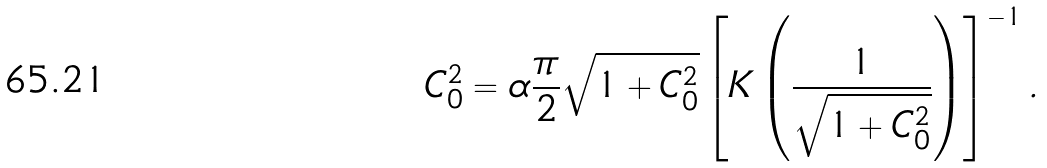<formula> <loc_0><loc_0><loc_500><loc_500>C _ { 0 } ^ { 2 } = \alpha \frac { \pi } { 2 } \sqrt { 1 + C _ { 0 } ^ { 2 } } \left [ K \left ( \frac { 1 } { \sqrt { 1 + C _ { 0 } ^ { 2 } } } \right ) \right ] ^ { - 1 } .</formula> 